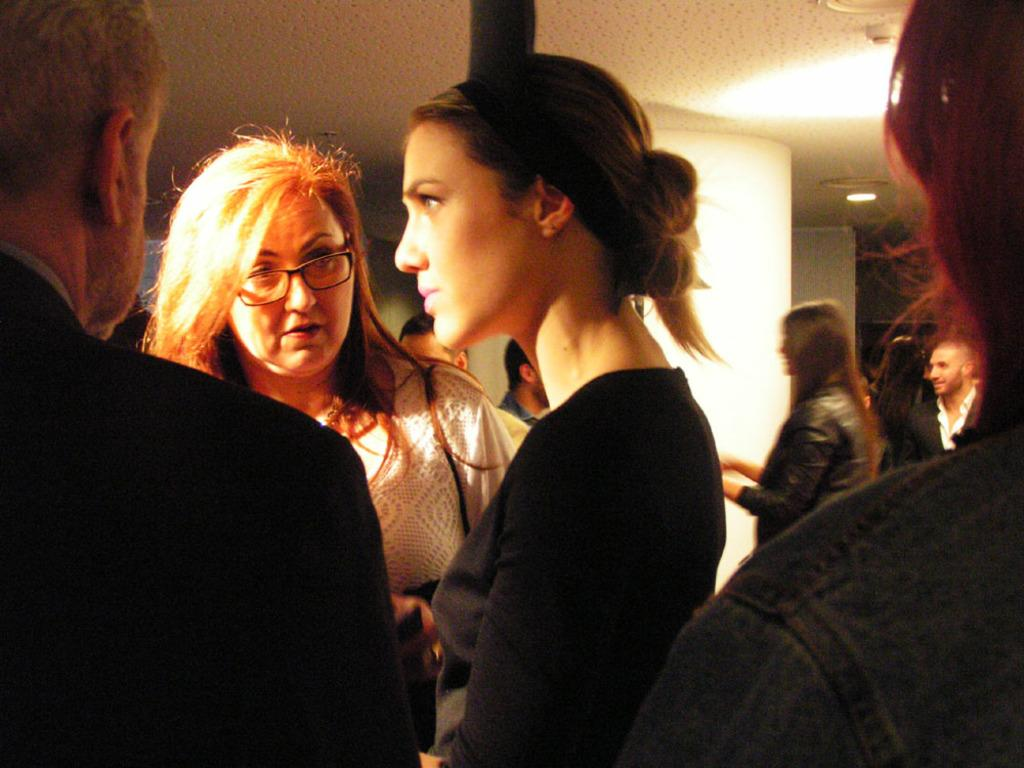Who or what can be seen in the image? There are people in the image. What else is visible in the image besides the people? There are lights and other objects in the image. How many times did the whip crack in the image? There is no whip present in the image, so it is not possible to determine how many times it cracked. 